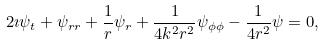<formula> <loc_0><loc_0><loc_500><loc_500>2 \imath \psi _ { t } + \psi _ { r r } + \frac { 1 } { r } \psi _ { r } + \frac { 1 } { 4 k ^ { 2 } r ^ { 2 } } \psi _ { \phi \phi } - \frac { 1 } { 4 r ^ { 2 } } \psi = 0 ,</formula> 